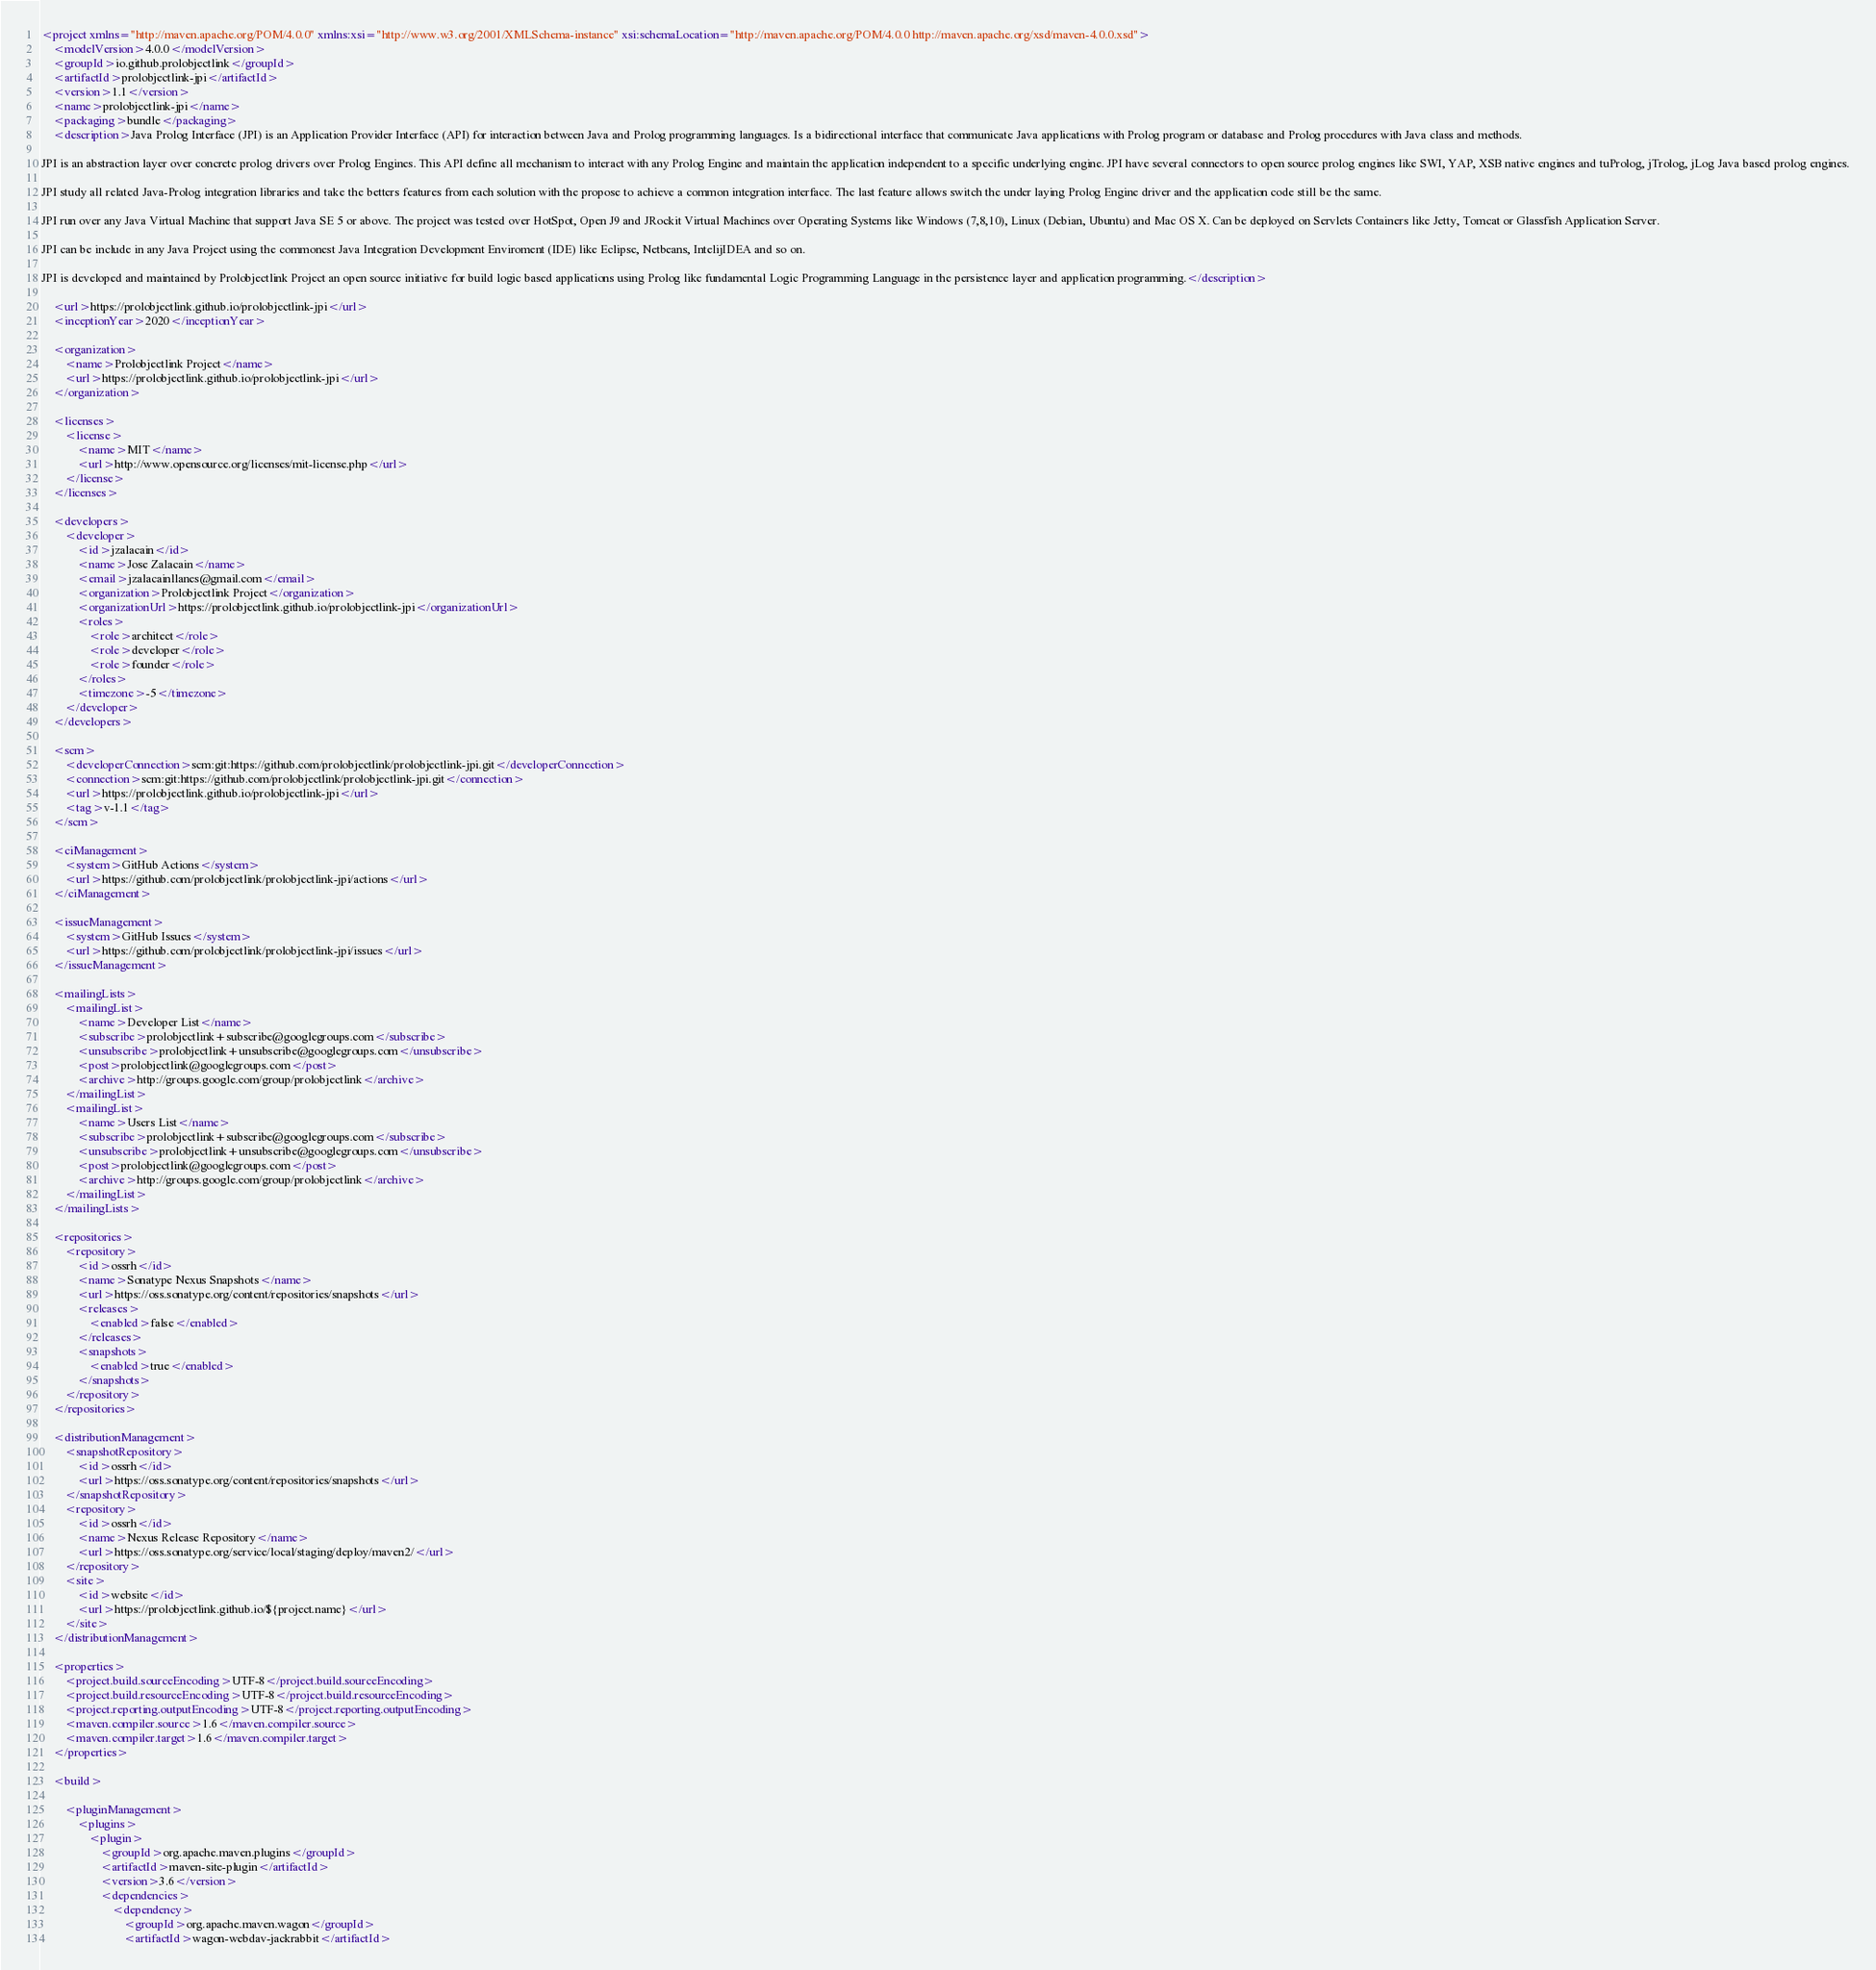Convert code to text. <code><loc_0><loc_0><loc_500><loc_500><_XML_><project xmlns="http://maven.apache.org/POM/4.0.0" xmlns:xsi="http://www.w3.org/2001/XMLSchema-instance" xsi:schemaLocation="http://maven.apache.org/POM/4.0.0 http://maven.apache.org/xsd/maven-4.0.0.xsd">
	<modelVersion>4.0.0</modelVersion>
	<groupId>io.github.prolobjectlink</groupId>
	<artifactId>prolobjectlink-jpi</artifactId>
	<version>1.1</version>
	<name>prolobjectlink-jpi</name>
	<packaging>bundle</packaging>
	<description>Java Prolog Interface (JPI) is an Application Provider Interface (API) for interaction between Java and Prolog programming languages. Is a bidirectional interface that communicate Java applications with Prolog program or database and Prolog procedures with Java class and methods.

JPI is an abstraction layer over concrete prolog drivers over Prolog Engines. This API define all mechanism to interact with any Prolog Engine and maintain the application independent to a specific underlying engine. JPI have several connectors to open source prolog engines like SWI, YAP, XSB native engines and tuProlog, jTrolog, jLog Java based prolog engines.

JPI study all related Java-Prolog integration libraries and take the betters features from each solution with the propose to achieve a common integration interface. The last feature allows switch the under laying Prolog Engine driver and the application code still be the same.

JPI run over any Java Virtual Machine that support Java SE 5 or above. The project was tested over HotSpot, Open J9 and JRockit Virtual Machines over Operating Systems like Windows (7,8,10), Linux (Debian, Ubuntu) and Mac OS X. Can be deployed on Servlets Containers like Jetty, Tomcat or Glassfish Application Server.

JPI can be include in any Java Project using the commonest Java Integration Development Enviroment (IDE) like Eclipse, Netbeans, IntelijIDEA and so on.

JPI is developed and maintained by Prolobjectlink Project an open source initiative for build logic based applications using Prolog like fundamental Logic Programming Language in the persistence layer and application programming.</description>

	<url>https://prolobjectlink.github.io/prolobjectlink-jpi</url>
	<inceptionYear>2020</inceptionYear>

	<organization>
		<name>Prolobjectlink Project</name>
		<url>https://prolobjectlink.github.io/prolobjectlink-jpi</url>
	</organization>

	<licenses>
		<license>
			<name>MIT</name>
			<url>http://www.opensource.org/licenses/mit-license.php</url>
		</license>
	</licenses>

	<developers>
		<developer>
			<id>jzalacain</id>
			<name>Jose Zalacain</name>
			<email>jzalacainllanes@gmail.com</email>
			<organization>Prolobjectlink Project</organization>
			<organizationUrl>https://prolobjectlink.github.io/prolobjectlink-jpi</organizationUrl>
			<roles>
				<role>architect</role>
				<role>developer</role>
				<role>founder</role>
			</roles>
			<timezone>-5</timezone>
		</developer>
	</developers>

	<scm>
		<developerConnection>scm:git:https://github.com/prolobjectlink/prolobjectlink-jpi.git</developerConnection>
		<connection>scm:git:https://github.com/prolobjectlink/prolobjectlink-jpi.git</connection>
		<url>https://prolobjectlink.github.io/prolobjectlink-jpi</url>
		<tag>v-1.1</tag>
	</scm>

	<ciManagement>
		<system>GitHub Actions</system>
		<url>https://github.com/prolobjectlink/prolobjectlink-jpi/actions</url>
	</ciManagement>

	<issueManagement>
		<system>GitHub Issues</system>
		<url>https://github.com/prolobjectlink/prolobjectlink-jpi/issues</url>
	</issueManagement>

	<mailingLists>
		<mailingList>
			<name>Developer List</name>
			<subscribe>prolobjectlink+subscribe@googlegroups.com</subscribe>
			<unsubscribe>prolobjectlink+unsubscribe@googlegroups.com</unsubscribe>
			<post>prolobjectlink@googlegroups.com</post>
			<archive>http://groups.google.com/group/prolobjectlink</archive>
		</mailingList>
		<mailingList>
			<name>Users List</name>
			<subscribe>prolobjectlink+subscribe@googlegroups.com</subscribe>
			<unsubscribe>prolobjectlink+unsubscribe@googlegroups.com</unsubscribe>
			<post>prolobjectlink@googlegroups.com</post>
			<archive>http://groups.google.com/group/prolobjectlink</archive>
		</mailingList>
	</mailingLists>

	<repositories>
		<repository>
			<id>ossrh</id>
			<name>Sonatype Nexus Snapshots</name>
			<url>https://oss.sonatype.org/content/repositories/snapshots</url>
			<releases>
				<enabled>false</enabled>
			</releases>
			<snapshots>
				<enabled>true</enabled>
			</snapshots>
		</repository>
	</repositories>

	<distributionManagement>
		<snapshotRepository>
			<id>ossrh</id>
			<url>https://oss.sonatype.org/content/repositories/snapshots</url>
		</snapshotRepository>
		<repository>
			<id>ossrh</id>
			<name>Nexus Release Repository</name>
			<url>https://oss.sonatype.org/service/local/staging/deploy/maven2/</url>
		</repository>
		<site>
			<id>website</id>
			<url>https://prolobjectlink.github.io/${project.name}</url>
		</site>
	</distributionManagement>

	<properties>
		<project.build.sourceEncoding>UTF-8</project.build.sourceEncoding>
		<project.build.resourceEncoding>UTF-8</project.build.resourceEncoding>
		<project.reporting.outputEncoding>UTF-8</project.reporting.outputEncoding>
		<maven.compiler.source>1.6</maven.compiler.source>
		<maven.compiler.target>1.6</maven.compiler.target>
	</properties>

	<build>

		<pluginManagement>
			<plugins>
				<plugin>
					<groupId>org.apache.maven.plugins</groupId>
					<artifactId>maven-site-plugin</artifactId>
					<version>3.6</version>
					<dependencies>
						<dependency>
							<groupId>org.apache.maven.wagon</groupId>
							<artifactId>wagon-webdav-jackrabbit</artifactId></code> 